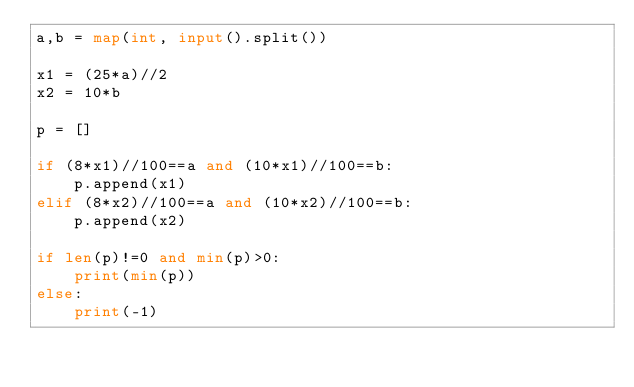Convert code to text. <code><loc_0><loc_0><loc_500><loc_500><_Python_>a,b = map(int, input().split())

x1 = (25*a)//2
x2 = 10*b

p = []

if (8*x1)//100==a and (10*x1)//100==b:
    p.append(x1)
elif (8*x2)//100==a and (10*x2)//100==b:
    p.append(x2)

if len(p)!=0 and min(p)>0:
    print(min(p))
else:
    print(-1)

    
</code> 